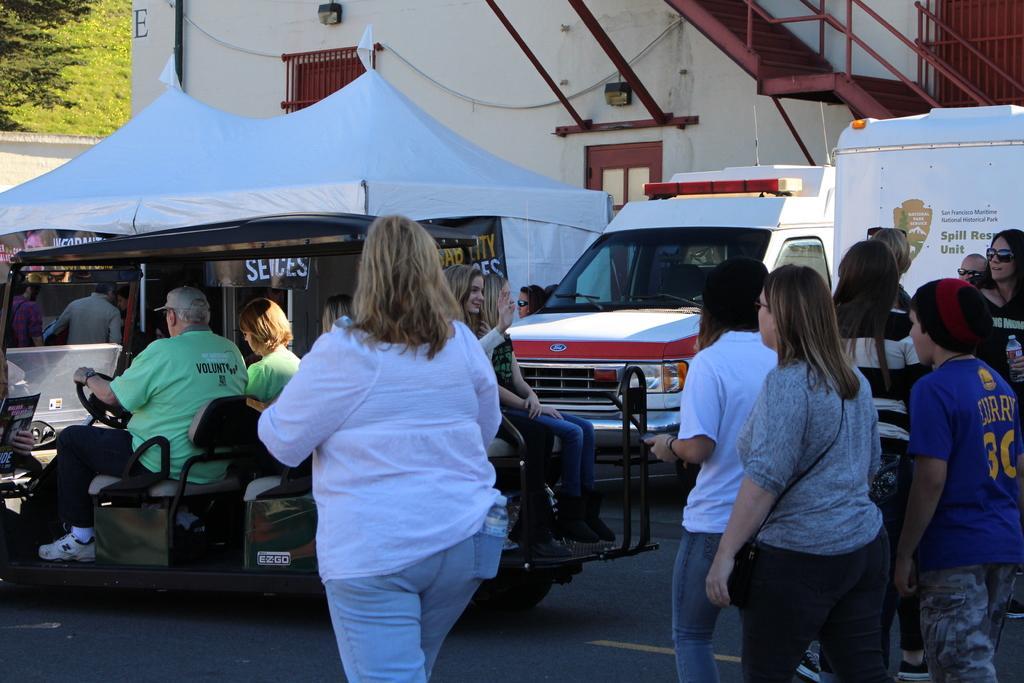Could you give a brief overview of what you see in this image? In this image a woman wearing a white top is having a bottle in her pocket. Beside her there is a vehicle having few persons sitting in it. Behind there is a tent. Few persons are under the tent. Right side there are few persons are walking on the road. Behind there are few vehicles. Top of image there is a building having staircase and a window. Left top there are few trees behind the wall. 